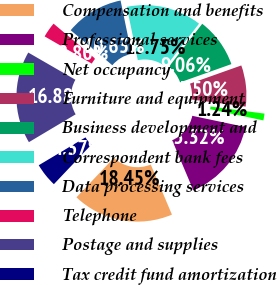Convert chart to OTSL. <chart><loc_0><loc_0><loc_500><loc_500><pie_chart><fcel>Compensation and benefits<fcel>Professional services<fcel>Net occupancy<fcel>Furniture and equipment<fcel>Business development and<fcel>Correspondent bank fees<fcel>Data processing services<fcel>Telephone<fcel>Postage and supplies<fcel>Tax credit fund amortization<nl><fcel>18.45%<fcel>15.32%<fcel>1.24%<fcel>7.5%<fcel>9.06%<fcel>13.75%<fcel>10.63%<fcel>2.8%<fcel>16.88%<fcel>4.37%<nl></chart> 